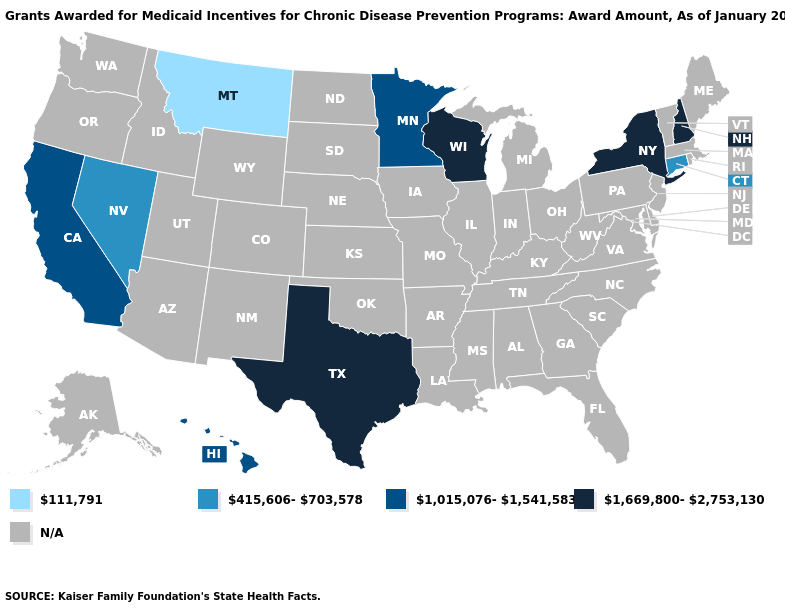What is the highest value in the Northeast ?
Write a very short answer. 1,669,800-2,753,130. Name the states that have a value in the range 111,791?
Answer briefly. Montana. Does Texas have the highest value in the USA?
Write a very short answer. Yes. What is the value of Kansas?
Concise answer only. N/A. What is the value of Utah?
Concise answer only. N/A. What is the value of Florida?
Give a very brief answer. N/A. Does the map have missing data?
Answer briefly. Yes. Which states have the lowest value in the MidWest?
Keep it brief. Minnesota. What is the highest value in the Northeast ?
Concise answer only. 1,669,800-2,753,130. Name the states that have a value in the range 1,669,800-2,753,130?
Write a very short answer. New Hampshire, New York, Texas, Wisconsin. Does New York have the highest value in the USA?
Write a very short answer. Yes. Is the legend a continuous bar?
Short answer required. No. What is the value of Louisiana?
Quick response, please. N/A. What is the lowest value in states that border Minnesota?
Answer briefly. 1,669,800-2,753,130. 